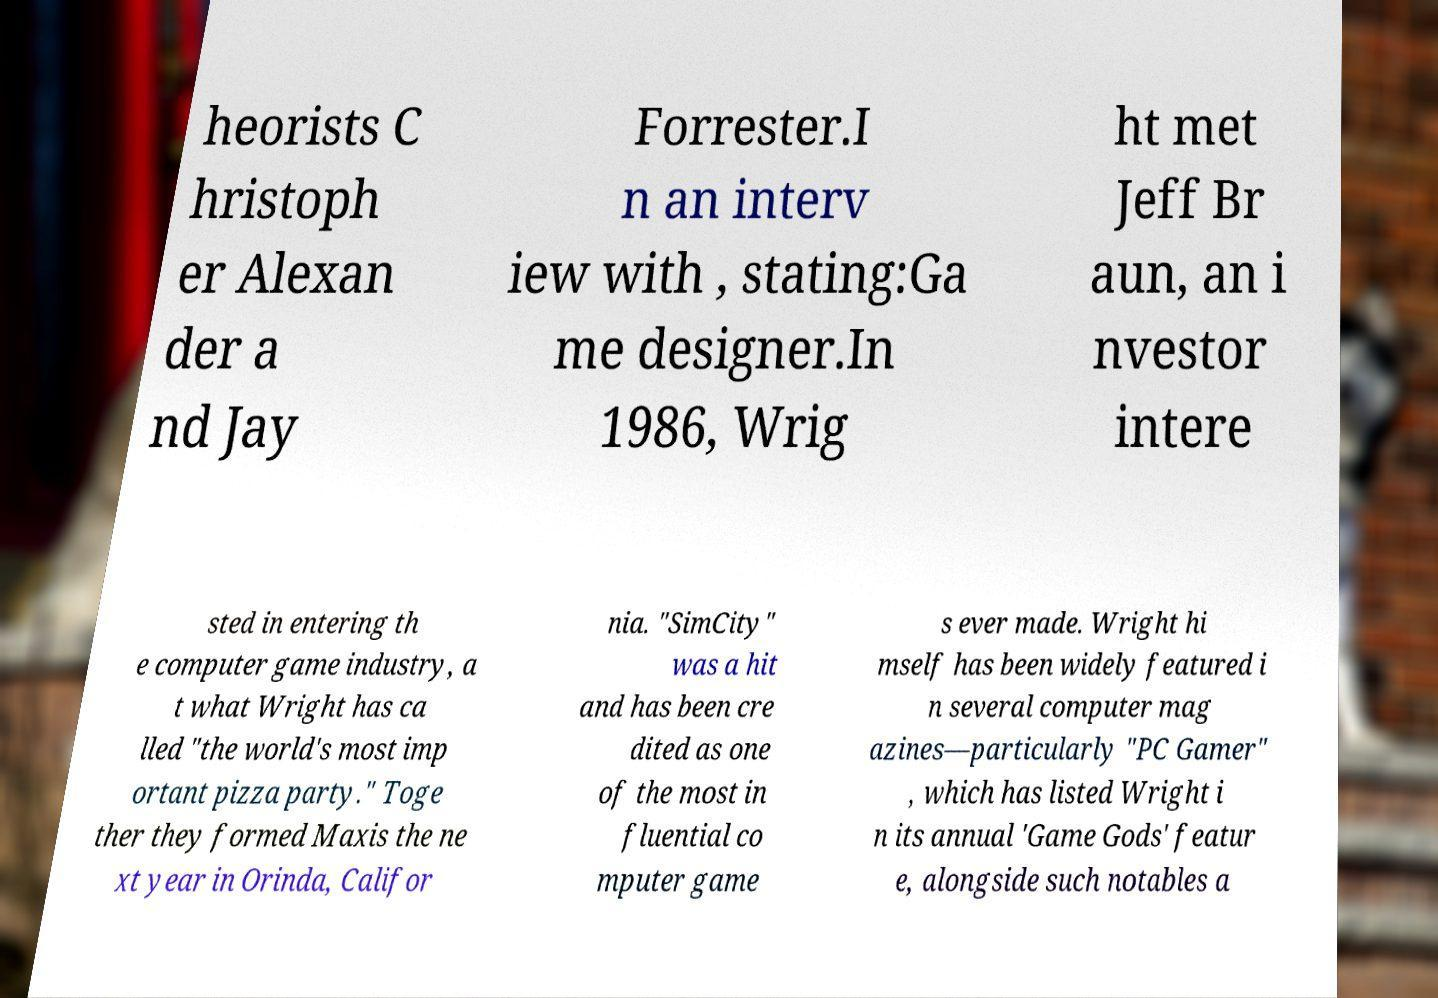There's text embedded in this image that I need extracted. Can you transcribe it verbatim? heorists C hristoph er Alexan der a nd Jay Forrester.I n an interv iew with , stating:Ga me designer.In 1986, Wrig ht met Jeff Br aun, an i nvestor intere sted in entering th e computer game industry, a t what Wright has ca lled "the world's most imp ortant pizza party." Toge ther they formed Maxis the ne xt year in Orinda, Califor nia. "SimCity" was a hit and has been cre dited as one of the most in fluential co mputer game s ever made. Wright hi mself has been widely featured i n several computer mag azines—particularly "PC Gamer" , which has listed Wright i n its annual 'Game Gods' featur e, alongside such notables a 